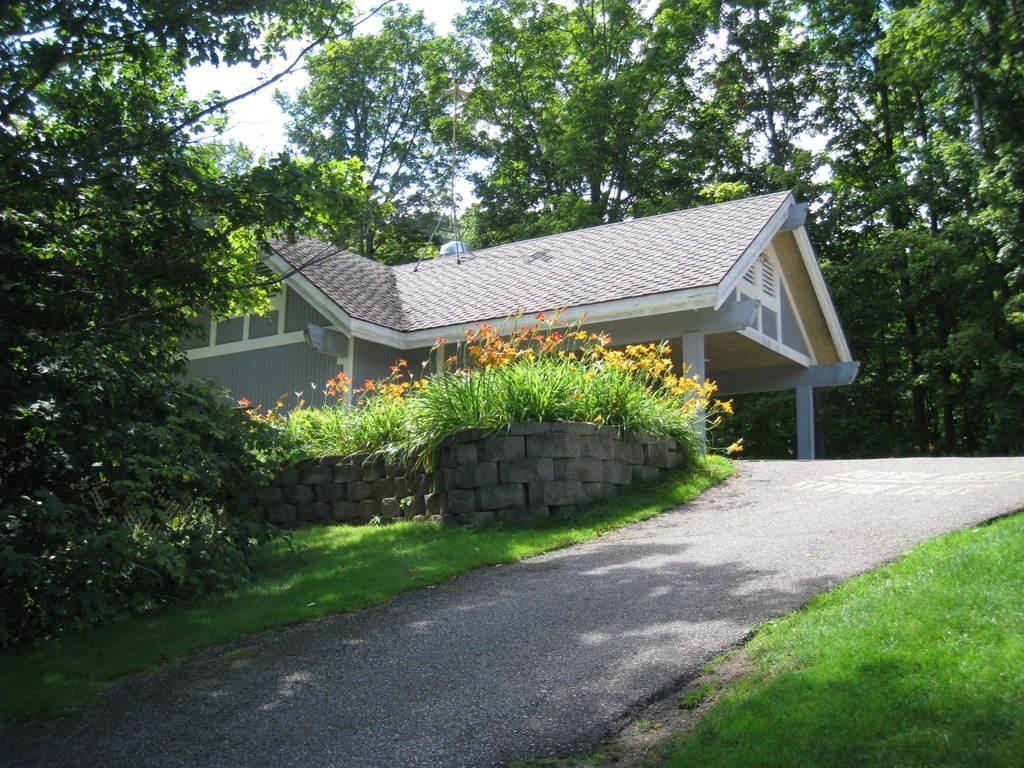What is located at the bottom of the image? There is a road at the bottom of the image. What can be seen in the middle of the image? There is a house and rocks in the middle of the image. What type of vegetation is visible in the background of the image? There are trees in the background of the image. How many ants can be seen carrying the maid's clothes in the image? There are no ants or maids present in the image. What type of cloud is visible in the image? There is no cloud visible in the image; only a road, a house, rocks, and trees are present. 